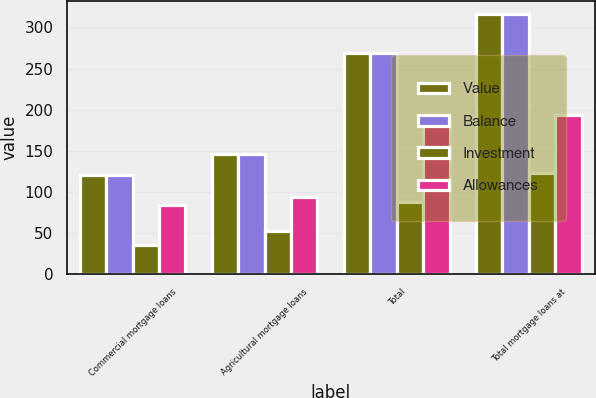Convert chart to OTSL. <chart><loc_0><loc_0><loc_500><loc_500><stacked_bar_chart><ecel><fcel>Commercial mortgage loans<fcel>Agricultural mortgage loans<fcel>Total<fcel>Total mortgage loans at<nl><fcel>Value<fcel>120<fcel>146<fcel>269<fcel>316<nl><fcel>Balance<fcel>120<fcel>146<fcel>269<fcel>316<nl><fcel>Investment<fcel>36<fcel>52<fcel>88<fcel>123<nl><fcel>Allowances<fcel>84<fcel>94<fcel>181<fcel>193<nl></chart> 